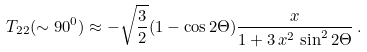Convert formula to latex. <formula><loc_0><loc_0><loc_500><loc_500>T _ { 2 2 } ( \sim 9 0 ^ { 0 } ) \approx - \sqrt { \frac { 3 } { 2 } } ( 1 - \cos { 2 \Theta } ) \frac { x } { 1 + 3 \, x ^ { 2 } \, \sin ^ { 2 } { 2 \Theta } } \, .</formula> 